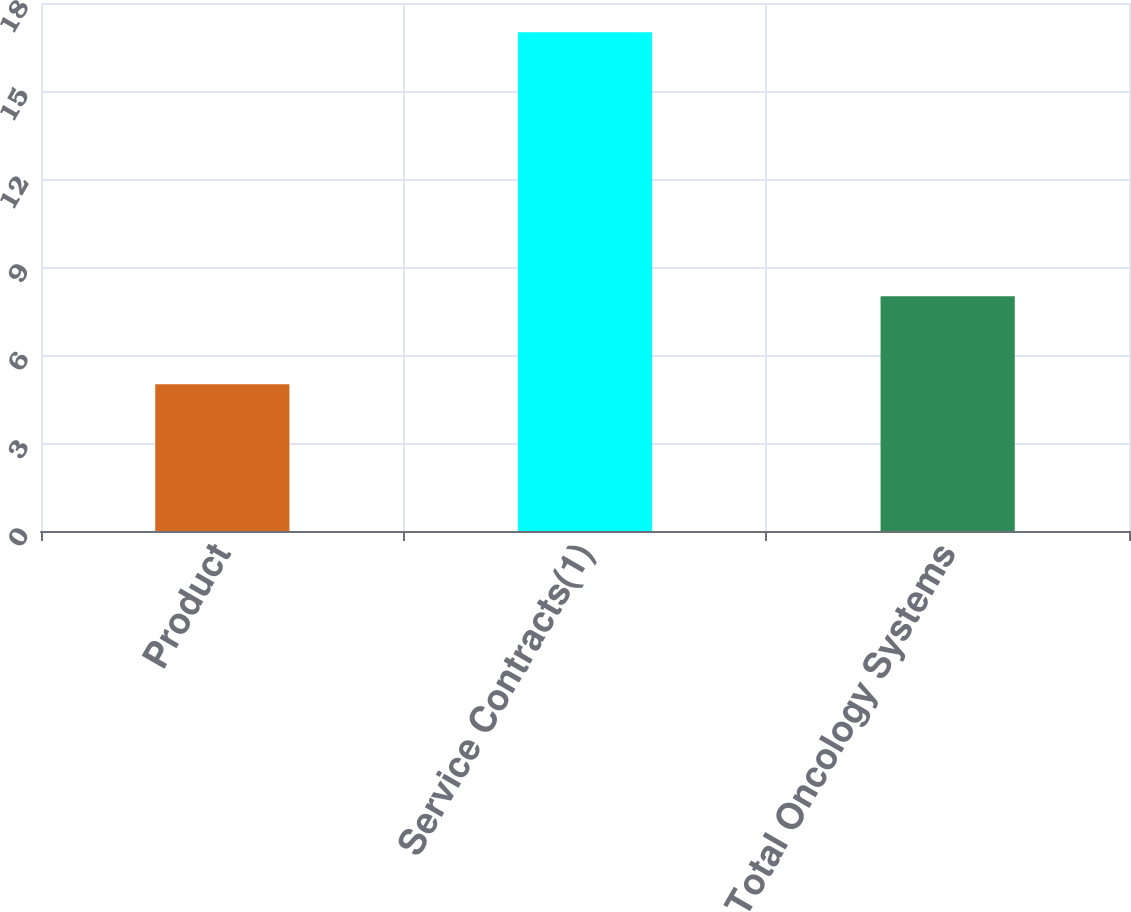<chart> <loc_0><loc_0><loc_500><loc_500><bar_chart><fcel>Product<fcel>Service Contracts(1)<fcel>Total Oncology Systems<nl><fcel>5<fcel>17<fcel>8<nl></chart> 